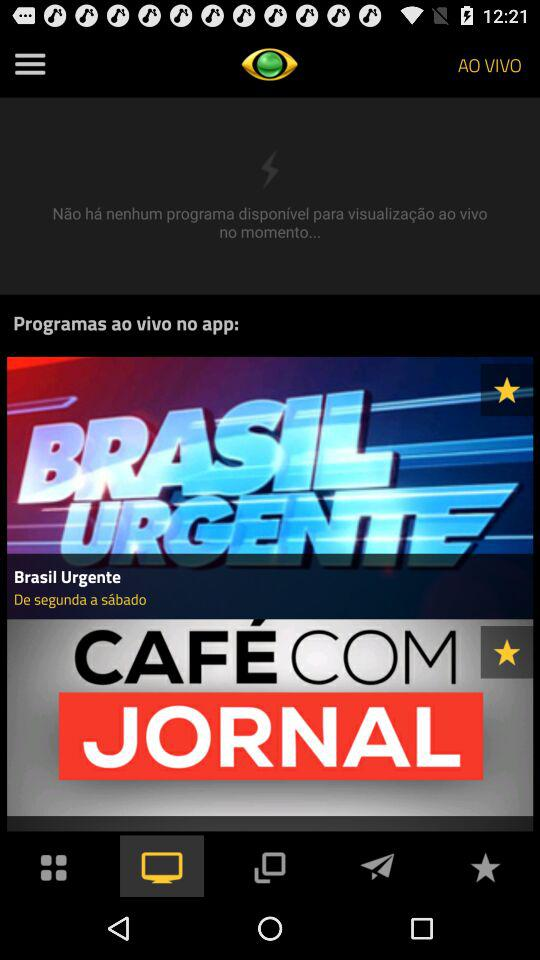How many programs are available on the app?
Answer the question using a single word or phrase. 2 